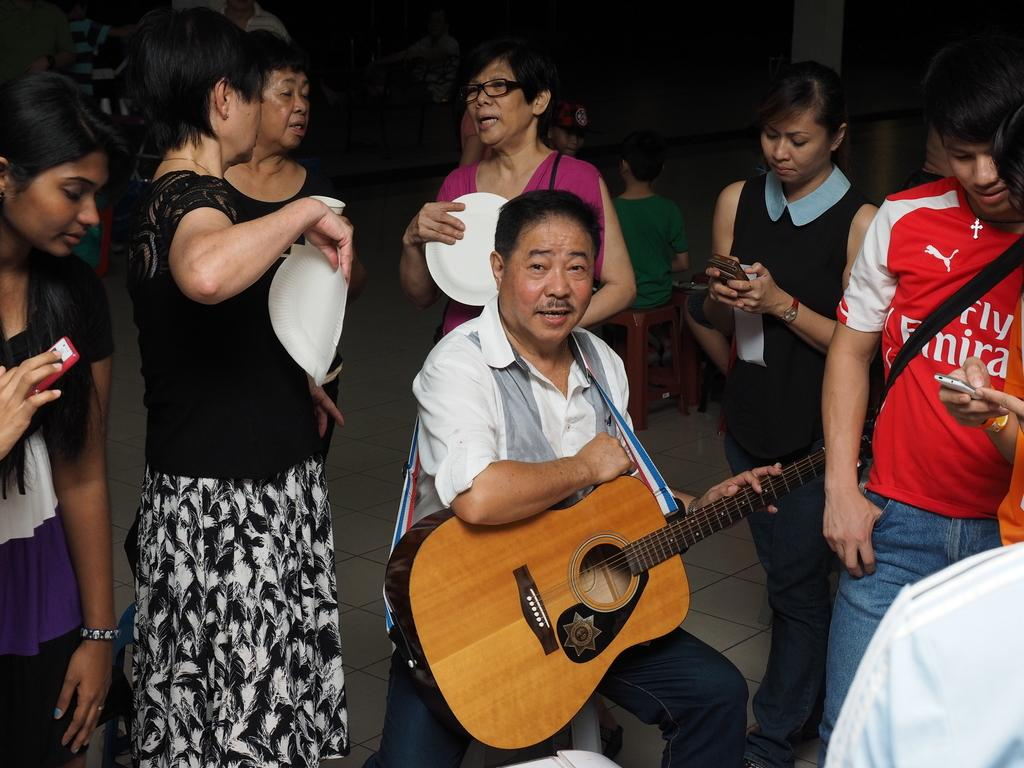What is the man in the white shirt holding in the image? The man in the white shirt is holding a guitar. Can you describe the people in the background of the image? There are many people standing in the background. What is the person in the red t-shirt holding in the image? The person in the red t-shirt is holding a bag. Who is standing next to the person in the red t-shirt? There is a lady next to the person in the red t-shirt. What is the lady holding in the image? The lady is holding a mobile. What type of basketball court can be seen in the image? There is no basketball court present in the image. What is the color of the floor in the image? The image does not show a floor, so it cannot be determined what color it is. 